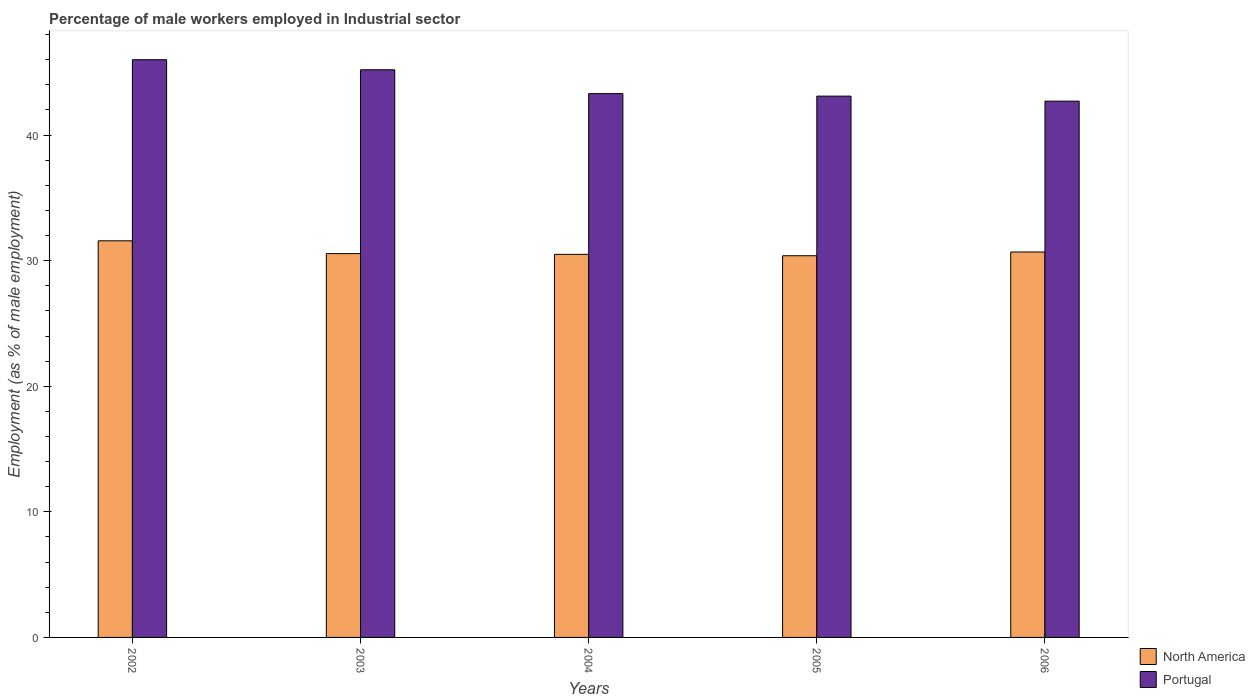How many groups of bars are there?
Your response must be concise. 5. Are the number of bars per tick equal to the number of legend labels?
Provide a succinct answer. Yes. How many bars are there on the 5th tick from the left?
Keep it short and to the point. 2. In how many cases, is the number of bars for a given year not equal to the number of legend labels?
Offer a very short reply. 0. What is the percentage of male workers employed in Industrial sector in North America in 2002?
Provide a short and direct response. 31.58. Across all years, what is the maximum percentage of male workers employed in Industrial sector in North America?
Provide a succinct answer. 31.58. Across all years, what is the minimum percentage of male workers employed in Industrial sector in North America?
Offer a very short reply. 30.39. What is the total percentage of male workers employed in Industrial sector in Portugal in the graph?
Offer a very short reply. 220.3. What is the difference between the percentage of male workers employed in Industrial sector in North America in 2004 and that in 2005?
Offer a very short reply. 0.11. What is the difference between the percentage of male workers employed in Industrial sector in North America in 2006 and the percentage of male workers employed in Industrial sector in Portugal in 2004?
Offer a terse response. -12.61. What is the average percentage of male workers employed in Industrial sector in North America per year?
Provide a short and direct response. 30.75. In the year 2003, what is the difference between the percentage of male workers employed in Industrial sector in Portugal and percentage of male workers employed in Industrial sector in North America?
Give a very brief answer. 14.64. What is the ratio of the percentage of male workers employed in Industrial sector in North America in 2002 to that in 2004?
Ensure brevity in your answer.  1.04. Is the percentage of male workers employed in Industrial sector in Portugal in 2003 less than that in 2004?
Offer a very short reply. No. Is the difference between the percentage of male workers employed in Industrial sector in Portugal in 2002 and 2004 greater than the difference between the percentage of male workers employed in Industrial sector in North America in 2002 and 2004?
Your response must be concise. Yes. What is the difference between the highest and the second highest percentage of male workers employed in Industrial sector in Portugal?
Ensure brevity in your answer.  0.8. What is the difference between the highest and the lowest percentage of male workers employed in Industrial sector in Portugal?
Offer a very short reply. 3.3. In how many years, is the percentage of male workers employed in Industrial sector in North America greater than the average percentage of male workers employed in Industrial sector in North America taken over all years?
Your response must be concise. 1. Is the sum of the percentage of male workers employed in Industrial sector in North America in 2002 and 2004 greater than the maximum percentage of male workers employed in Industrial sector in Portugal across all years?
Provide a succinct answer. Yes. What does the 1st bar from the left in 2006 represents?
Your answer should be very brief. North America. Are the values on the major ticks of Y-axis written in scientific E-notation?
Ensure brevity in your answer.  No. Does the graph contain grids?
Keep it short and to the point. No. What is the title of the graph?
Your response must be concise. Percentage of male workers employed in Industrial sector. Does "Senegal" appear as one of the legend labels in the graph?
Offer a terse response. No. What is the label or title of the Y-axis?
Give a very brief answer. Employment (as % of male employment). What is the Employment (as % of male employment) of North America in 2002?
Your answer should be compact. 31.58. What is the Employment (as % of male employment) of North America in 2003?
Offer a very short reply. 30.56. What is the Employment (as % of male employment) of Portugal in 2003?
Give a very brief answer. 45.2. What is the Employment (as % of male employment) in North America in 2004?
Keep it short and to the point. 30.5. What is the Employment (as % of male employment) in Portugal in 2004?
Provide a short and direct response. 43.3. What is the Employment (as % of male employment) in North America in 2005?
Offer a terse response. 30.39. What is the Employment (as % of male employment) in Portugal in 2005?
Your answer should be very brief. 43.1. What is the Employment (as % of male employment) in North America in 2006?
Keep it short and to the point. 30.69. What is the Employment (as % of male employment) of Portugal in 2006?
Offer a terse response. 42.7. Across all years, what is the maximum Employment (as % of male employment) of North America?
Offer a terse response. 31.58. Across all years, what is the maximum Employment (as % of male employment) in Portugal?
Provide a succinct answer. 46. Across all years, what is the minimum Employment (as % of male employment) in North America?
Make the answer very short. 30.39. Across all years, what is the minimum Employment (as % of male employment) of Portugal?
Offer a very short reply. 42.7. What is the total Employment (as % of male employment) of North America in the graph?
Ensure brevity in your answer.  153.73. What is the total Employment (as % of male employment) in Portugal in the graph?
Keep it short and to the point. 220.3. What is the difference between the Employment (as % of male employment) in North America in 2002 and that in 2003?
Offer a very short reply. 1.02. What is the difference between the Employment (as % of male employment) in Portugal in 2002 and that in 2003?
Ensure brevity in your answer.  0.8. What is the difference between the Employment (as % of male employment) of North America in 2002 and that in 2004?
Your answer should be compact. 1.08. What is the difference between the Employment (as % of male employment) in North America in 2002 and that in 2005?
Provide a succinct answer. 1.19. What is the difference between the Employment (as % of male employment) of Portugal in 2002 and that in 2005?
Your answer should be very brief. 2.9. What is the difference between the Employment (as % of male employment) in Portugal in 2002 and that in 2006?
Your answer should be very brief. 3.3. What is the difference between the Employment (as % of male employment) of North America in 2003 and that in 2004?
Offer a terse response. 0.06. What is the difference between the Employment (as % of male employment) in North America in 2003 and that in 2005?
Provide a short and direct response. 0.17. What is the difference between the Employment (as % of male employment) of Portugal in 2003 and that in 2005?
Keep it short and to the point. 2.1. What is the difference between the Employment (as % of male employment) of North America in 2003 and that in 2006?
Ensure brevity in your answer.  -0.13. What is the difference between the Employment (as % of male employment) in North America in 2004 and that in 2005?
Make the answer very short. 0.11. What is the difference between the Employment (as % of male employment) of Portugal in 2004 and that in 2005?
Offer a very short reply. 0.2. What is the difference between the Employment (as % of male employment) of North America in 2004 and that in 2006?
Your answer should be compact. -0.19. What is the difference between the Employment (as % of male employment) in Portugal in 2004 and that in 2006?
Provide a short and direct response. 0.6. What is the difference between the Employment (as % of male employment) of North America in 2005 and that in 2006?
Your answer should be compact. -0.3. What is the difference between the Employment (as % of male employment) of Portugal in 2005 and that in 2006?
Your response must be concise. 0.4. What is the difference between the Employment (as % of male employment) in North America in 2002 and the Employment (as % of male employment) in Portugal in 2003?
Your answer should be very brief. -13.62. What is the difference between the Employment (as % of male employment) in North America in 2002 and the Employment (as % of male employment) in Portugal in 2004?
Ensure brevity in your answer.  -11.72. What is the difference between the Employment (as % of male employment) of North America in 2002 and the Employment (as % of male employment) of Portugal in 2005?
Ensure brevity in your answer.  -11.52. What is the difference between the Employment (as % of male employment) of North America in 2002 and the Employment (as % of male employment) of Portugal in 2006?
Offer a very short reply. -11.12. What is the difference between the Employment (as % of male employment) of North America in 2003 and the Employment (as % of male employment) of Portugal in 2004?
Offer a terse response. -12.74. What is the difference between the Employment (as % of male employment) of North America in 2003 and the Employment (as % of male employment) of Portugal in 2005?
Give a very brief answer. -12.54. What is the difference between the Employment (as % of male employment) of North America in 2003 and the Employment (as % of male employment) of Portugal in 2006?
Your response must be concise. -12.14. What is the difference between the Employment (as % of male employment) in North America in 2004 and the Employment (as % of male employment) in Portugal in 2005?
Ensure brevity in your answer.  -12.6. What is the difference between the Employment (as % of male employment) in North America in 2004 and the Employment (as % of male employment) in Portugal in 2006?
Offer a terse response. -12.2. What is the difference between the Employment (as % of male employment) in North America in 2005 and the Employment (as % of male employment) in Portugal in 2006?
Your answer should be compact. -12.31. What is the average Employment (as % of male employment) of North America per year?
Provide a succinct answer. 30.75. What is the average Employment (as % of male employment) of Portugal per year?
Offer a terse response. 44.06. In the year 2002, what is the difference between the Employment (as % of male employment) in North America and Employment (as % of male employment) in Portugal?
Your answer should be compact. -14.42. In the year 2003, what is the difference between the Employment (as % of male employment) of North America and Employment (as % of male employment) of Portugal?
Provide a short and direct response. -14.64. In the year 2004, what is the difference between the Employment (as % of male employment) of North America and Employment (as % of male employment) of Portugal?
Ensure brevity in your answer.  -12.8. In the year 2005, what is the difference between the Employment (as % of male employment) of North America and Employment (as % of male employment) of Portugal?
Give a very brief answer. -12.71. In the year 2006, what is the difference between the Employment (as % of male employment) in North America and Employment (as % of male employment) in Portugal?
Offer a very short reply. -12.01. What is the ratio of the Employment (as % of male employment) of Portugal in 2002 to that in 2003?
Provide a succinct answer. 1.02. What is the ratio of the Employment (as % of male employment) of North America in 2002 to that in 2004?
Keep it short and to the point. 1.04. What is the ratio of the Employment (as % of male employment) of Portugal in 2002 to that in 2004?
Your response must be concise. 1.06. What is the ratio of the Employment (as % of male employment) in North America in 2002 to that in 2005?
Ensure brevity in your answer.  1.04. What is the ratio of the Employment (as % of male employment) in Portugal in 2002 to that in 2005?
Make the answer very short. 1.07. What is the ratio of the Employment (as % of male employment) in Portugal in 2002 to that in 2006?
Offer a terse response. 1.08. What is the ratio of the Employment (as % of male employment) of Portugal in 2003 to that in 2004?
Make the answer very short. 1.04. What is the ratio of the Employment (as % of male employment) in North America in 2003 to that in 2005?
Offer a very short reply. 1.01. What is the ratio of the Employment (as % of male employment) in Portugal in 2003 to that in 2005?
Offer a terse response. 1.05. What is the ratio of the Employment (as % of male employment) in North America in 2003 to that in 2006?
Your answer should be very brief. 1. What is the ratio of the Employment (as % of male employment) of Portugal in 2003 to that in 2006?
Provide a succinct answer. 1.06. What is the ratio of the Employment (as % of male employment) in Portugal in 2004 to that in 2006?
Your answer should be compact. 1.01. What is the ratio of the Employment (as % of male employment) of North America in 2005 to that in 2006?
Make the answer very short. 0.99. What is the ratio of the Employment (as % of male employment) of Portugal in 2005 to that in 2006?
Your answer should be very brief. 1.01. What is the difference between the highest and the second highest Employment (as % of male employment) in North America?
Provide a succinct answer. 0.89. What is the difference between the highest and the lowest Employment (as % of male employment) of North America?
Your answer should be compact. 1.19. 